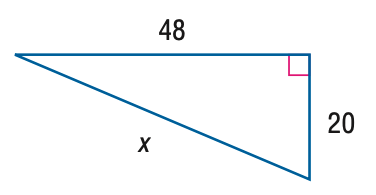Answer the mathemtical geometry problem and directly provide the correct option letter.
Question: Find x.
Choices: A: 50 B: 52 C: 54 D: 56 B 